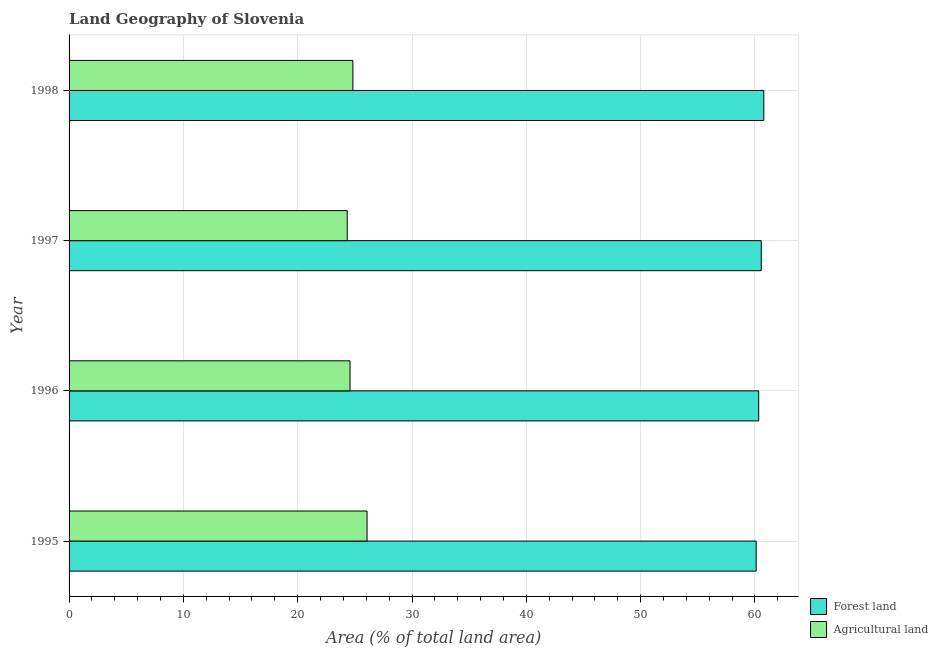How many different coloured bars are there?
Your answer should be compact. 2. Are the number of bars on each tick of the Y-axis equal?
Make the answer very short. Yes. How many bars are there on the 3rd tick from the top?
Offer a terse response. 2. What is the label of the 3rd group of bars from the top?
Your answer should be very brief. 1996. What is the percentage of land area under agriculture in 1998?
Offer a very short reply. 24.83. Across all years, what is the maximum percentage of land area under forests?
Ensure brevity in your answer.  60.77. Across all years, what is the minimum percentage of land area under forests?
Make the answer very short. 60.1. In which year was the percentage of land area under agriculture maximum?
Your answer should be compact. 1995. In which year was the percentage of land area under forests minimum?
Give a very brief answer. 1995. What is the total percentage of land area under agriculture in the graph?
Keep it short and to the point. 99.8. What is the difference between the percentage of land area under agriculture in 1995 and that in 1997?
Ensure brevity in your answer.  1.74. What is the difference between the percentage of land area under forests in 1995 and the percentage of land area under agriculture in 1996?
Give a very brief answer. 35.53. What is the average percentage of land area under forests per year?
Your response must be concise. 60.44. In the year 1996, what is the difference between the percentage of land area under forests and percentage of land area under agriculture?
Offer a terse response. 35.75. Is the percentage of land area under forests in 1995 less than that in 1996?
Keep it short and to the point. Yes. What is the difference between the highest and the second highest percentage of land area under agriculture?
Make the answer very short. 1.24. What is the difference between the highest and the lowest percentage of land area under agriculture?
Provide a short and direct response. 1.74. Is the sum of the percentage of land area under agriculture in 1997 and 1998 greater than the maximum percentage of land area under forests across all years?
Offer a terse response. No. What does the 1st bar from the top in 1995 represents?
Make the answer very short. Agricultural land. What does the 2nd bar from the bottom in 1997 represents?
Make the answer very short. Agricultural land. How many years are there in the graph?
Offer a terse response. 4. What is the difference between two consecutive major ticks on the X-axis?
Give a very brief answer. 10. Does the graph contain any zero values?
Ensure brevity in your answer.  No. Does the graph contain grids?
Your answer should be very brief. Yes. Where does the legend appear in the graph?
Make the answer very short. Bottom right. How many legend labels are there?
Offer a very short reply. 2. How are the legend labels stacked?
Provide a short and direct response. Vertical. What is the title of the graph?
Your response must be concise. Land Geography of Slovenia. What is the label or title of the X-axis?
Make the answer very short. Area (% of total land area). What is the Area (% of total land area) of Forest land in 1995?
Your response must be concise. 60.1. What is the Area (% of total land area) of Agricultural land in 1995?
Keep it short and to the point. 26.07. What is the Area (% of total land area) of Forest land in 1996?
Make the answer very short. 60.33. What is the Area (% of total land area) in Agricultural land in 1996?
Give a very brief answer. 24.58. What is the Area (% of total land area) of Forest land in 1997?
Keep it short and to the point. 60.55. What is the Area (% of total land area) of Agricultural land in 1997?
Give a very brief answer. 24.33. What is the Area (% of total land area) in Forest land in 1998?
Provide a succinct answer. 60.77. What is the Area (% of total land area) of Agricultural land in 1998?
Your answer should be compact. 24.83. Across all years, what is the maximum Area (% of total land area) in Forest land?
Offer a terse response. 60.77. Across all years, what is the maximum Area (% of total land area) of Agricultural land?
Your answer should be compact. 26.07. Across all years, what is the minimum Area (% of total land area) of Forest land?
Make the answer very short. 60.1. Across all years, what is the minimum Area (% of total land area) in Agricultural land?
Your response must be concise. 24.33. What is the total Area (% of total land area) of Forest land in the graph?
Keep it short and to the point. 241.76. What is the total Area (% of total land area) of Agricultural land in the graph?
Offer a very short reply. 99.8. What is the difference between the Area (% of total land area) of Forest land in 1995 and that in 1996?
Offer a terse response. -0.22. What is the difference between the Area (% of total land area) of Agricultural land in 1995 and that in 1996?
Give a very brief answer. 1.49. What is the difference between the Area (% of total land area) of Forest land in 1995 and that in 1997?
Give a very brief answer. -0.45. What is the difference between the Area (% of total land area) in Agricultural land in 1995 and that in 1997?
Your answer should be very brief. 1.74. What is the difference between the Area (% of total land area) of Forest land in 1995 and that in 1998?
Offer a terse response. -0.67. What is the difference between the Area (% of total land area) of Agricultural land in 1995 and that in 1998?
Make the answer very short. 1.24. What is the difference between the Area (% of total land area) of Forest land in 1996 and that in 1997?
Make the answer very short. -0.22. What is the difference between the Area (% of total land area) of Agricultural land in 1996 and that in 1997?
Make the answer very short. 0.25. What is the difference between the Area (% of total land area) of Forest land in 1996 and that in 1998?
Make the answer very short. -0.45. What is the difference between the Area (% of total land area) in Agricultural land in 1996 and that in 1998?
Make the answer very short. -0.25. What is the difference between the Area (% of total land area) in Forest land in 1997 and that in 1998?
Provide a succinct answer. -0.22. What is the difference between the Area (% of total land area) in Agricultural land in 1997 and that in 1998?
Ensure brevity in your answer.  -0.5. What is the difference between the Area (% of total land area) of Forest land in 1995 and the Area (% of total land area) of Agricultural land in 1996?
Ensure brevity in your answer.  35.53. What is the difference between the Area (% of total land area) in Forest land in 1995 and the Area (% of total land area) in Agricultural land in 1997?
Your answer should be very brief. 35.77. What is the difference between the Area (% of total land area) in Forest land in 1995 and the Area (% of total land area) in Agricultural land in 1998?
Make the answer very short. 35.28. What is the difference between the Area (% of total land area) of Forest land in 1996 and the Area (% of total land area) of Agricultural land in 1997?
Ensure brevity in your answer.  36. What is the difference between the Area (% of total land area) in Forest land in 1996 and the Area (% of total land area) in Agricultural land in 1998?
Make the answer very short. 35.5. What is the difference between the Area (% of total land area) in Forest land in 1997 and the Area (% of total land area) in Agricultural land in 1998?
Make the answer very short. 35.72. What is the average Area (% of total land area) of Forest land per year?
Your response must be concise. 60.44. What is the average Area (% of total land area) of Agricultural land per year?
Provide a succinct answer. 24.95. In the year 1995, what is the difference between the Area (% of total land area) in Forest land and Area (% of total land area) in Agricultural land?
Your response must be concise. 34.04. In the year 1996, what is the difference between the Area (% of total land area) in Forest land and Area (% of total land area) in Agricultural land?
Ensure brevity in your answer.  35.75. In the year 1997, what is the difference between the Area (% of total land area) of Forest land and Area (% of total land area) of Agricultural land?
Provide a succinct answer. 36.22. In the year 1998, what is the difference between the Area (% of total land area) of Forest land and Area (% of total land area) of Agricultural land?
Keep it short and to the point. 35.95. What is the ratio of the Area (% of total land area) of Forest land in 1995 to that in 1996?
Keep it short and to the point. 1. What is the ratio of the Area (% of total land area) in Agricultural land in 1995 to that in 1996?
Provide a short and direct response. 1.06. What is the ratio of the Area (% of total land area) of Forest land in 1995 to that in 1997?
Offer a terse response. 0.99. What is the ratio of the Area (% of total land area) in Agricultural land in 1995 to that in 1997?
Provide a succinct answer. 1.07. What is the ratio of the Area (% of total land area) in Agricultural land in 1995 to that in 1998?
Offer a very short reply. 1.05. What is the ratio of the Area (% of total land area) in Forest land in 1996 to that in 1997?
Your answer should be compact. 1. What is the ratio of the Area (% of total land area) of Agricultural land in 1996 to that in 1997?
Offer a very short reply. 1.01. What is the ratio of the Area (% of total land area) of Agricultural land in 1996 to that in 1998?
Your response must be concise. 0.99. What is the ratio of the Area (% of total land area) in Forest land in 1997 to that in 1998?
Provide a short and direct response. 1. What is the ratio of the Area (% of total land area) of Agricultural land in 1997 to that in 1998?
Offer a very short reply. 0.98. What is the difference between the highest and the second highest Area (% of total land area) in Forest land?
Your answer should be compact. 0.22. What is the difference between the highest and the second highest Area (% of total land area) in Agricultural land?
Make the answer very short. 1.24. What is the difference between the highest and the lowest Area (% of total land area) in Forest land?
Your response must be concise. 0.67. What is the difference between the highest and the lowest Area (% of total land area) of Agricultural land?
Your response must be concise. 1.74. 